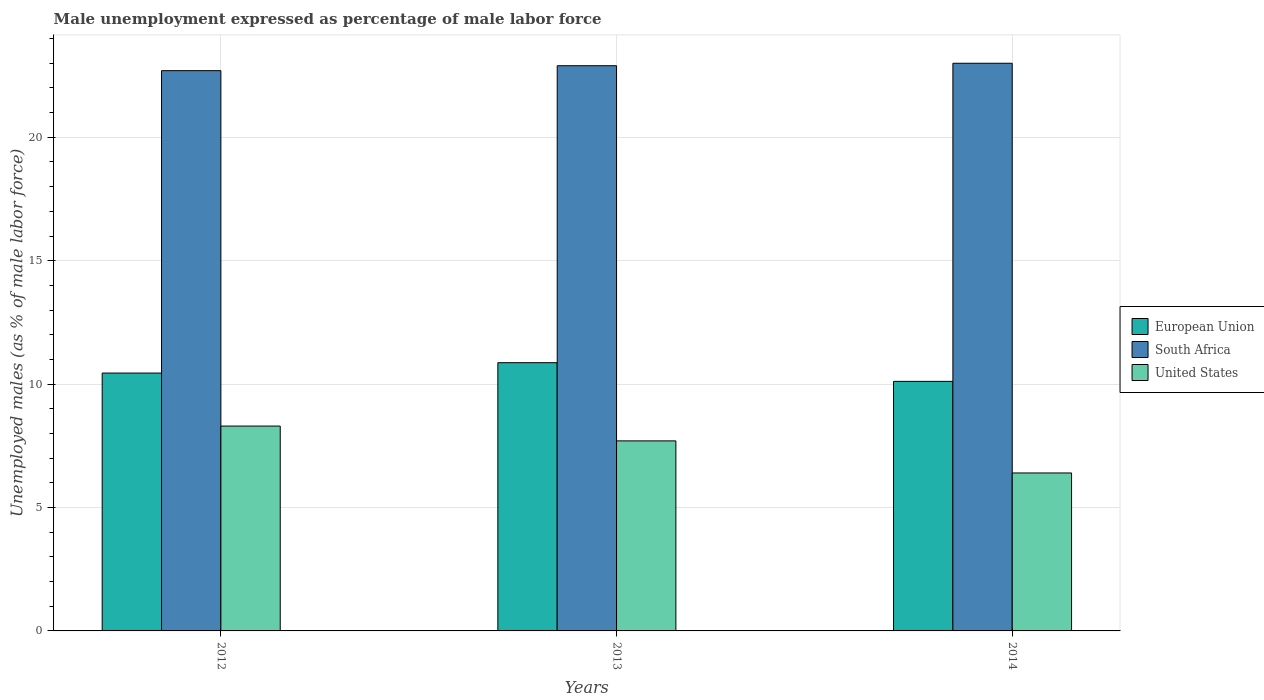How many groups of bars are there?
Provide a succinct answer. 3. Are the number of bars per tick equal to the number of legend labels?
Your answer should be compact. Yes. Are the number of bars on each tick of the X-axis equal?
Offer a terse response. Yes. How many bars are there on the 1st tick from the left?
Keep it short and to the point. 3. How many bars are there on the 2nd tick from the right?
Provide a short and direct response. 3. What is the label of the 1st group of bars from the left?
Give a very brief answer. 2012. What is the unemployment in males in in European Union in 2012?
Your answer should be very brief. 10.45. Across all years, what is the minimum unemployment in males in in United States?
Ensure brevity in your answer.  6.4. In which year was the unemployment in males in in European Union maximum?
Your answer should be very brief. 2013. In which year was the unemployment in males in in United States minimum?
Provide a succinct answer. 2014. What is the total unemployment in males in in United States in the graph?
Make the answer very short. 22.4. What is the difference between the unemployment in males in in South Africa in 2012 and that in 2013?
Give a very brief answer. -0.2. What is the difference between the unemployment in males in in South Africa in 2014 and the unemployment in males in in European Union in 2012?
Your answer should be very brief. 12.55. What is the average unemployment in males in in European Union per year?
Keep it short and to the point. 10.48. In the year 2012, what is the difference between the unemployment in males in in United States and unemployment in males in in South Africa?
Make the answer very short. -14.4. What is the ratio of the unemployment in males in in European Union in 2013 to that in 2014?
Provide a short and direct response. 1.07. Is the unemployment in males in in European Union in 2012 less than that in 2013?
Give a very brief answer. Yes. What is the difference between the highest and the second highest unemployment in males in in South Africa?
Your answer should be compact. 0.1. What is the difference between the highest and the lowest unemployment in males in in United States?
Provide a short and direct response. 1.9. In how many years, is the unemployment in males in in United States greater than the average unemployment in males in in United States taken over all years?
Keep it short and to the point. 2. Is it the case that in every year, the sum of the unemployment in males in in South Africa and unemployment in males in in European Union is greater than the unemployment in males in in United States?
Make the answer very short. Yes. How many years are there in the graph?
Your response must be concise. 3. Are the values on the major ticks of Y-axis written in scientific E-notation?
Offer a terse response. No. Does the graph contain grids?
Give a very brief answer. Yes. Where does the legend appear in the graph?
Your answer should be very brief. Center right. How are the legend labels stacked?
Offer a very short reply. Vertical. What is the title of the graph?
Provide a short and direct response. Male unemployment expressed as percentage of male labor force. What is the label or title of the X-axis?
Offer a very short reply. Years. What is the label or title of the Y-axis?
Give a very brief answer. Unemployed males (as % of male labor force). What is the Unemployed males (as % of male labor force) in European Union in 2012?
Keep it short and to the point. 10.45. What is the Unemployed males (as % of male labor force) in South Africa in 2012?
Provide a short and direct response. 22.7. What is the Unemployed males (as % of male labor force) of United States in 2012?
Make the answer very short. 8.3. What is the Unemployed males (as % of male labor force) in European Union in 2013?
Your answer should be compact. 10.87. What is the Unemployed males (as % of male labor force) of South Africa in 2013?
Give a very brief answer. 22.9. What is the Unemployed males (as % of male labor force) of United States in 2013?
Ensure brevity in your answer.  7.7. What is the Unemployed males (as % of male labor force) in European Union in 2014?
Provide a short and direct response. 10.11. What is the Unemployed males (as % of male labor force) of United States in 2014?
Provide a succinct answer. 6.4. Across all years, what is the maximum Unemployed males (as % of male labor force) of European Union?
Provide a succinct answer. 10.87. Across all years, what is the maximum Unemployed males (as % of male labor force) of South Africa?
Provide a short and direct response. 23. Across all years, what is the maximum Unemployed males (as % of male labor force) of United States?
Make the answer very short. 8.3. Across all years, what is the minimum Unemployed males (as % of male labor force) in European Union?
Your answer should be very brief. 10.11. Across all years, what is the minimum Unemployed males (as % of male labor force) of South Africa?
Ensure brevity in your answer.  22.7. Across all years, what is the minimum Unemployed males (as % of male labor force) in United States?
Provide a short and direct response. 6.4. What is the total Unemployed males (as % of male labor force) in European Union in the graph?
Ensure brevity in your answer.  31.43. What is the total Unemployed males (as % of male labor force) of South Africa in the graph?
Offer a terse response. 68.6. What is the total Unemployed males (as % of male labor force) of United States in the graph?
Offer a very short reply. 22.4. What is the difference between the Unemployed males (as % of male labor force) of European Union in 2012 and that in 2013?
Your response must be concise. -0.42. What is the difference between the Unemployed males (as % of male labor force) in South Africa in 2012 and that in 2013?
Provide a short and direct response. -0.2. What is the difference between the Unemployed males (as % of male labor force) of European Union in 2012 and that in 2014?
Provide a succinct answer. 0.34. What is the difference between the Unemployed males (as % of male labor force) in United States in 2012 and that in 2014?
Provide a short and direct response. 1.9. What is the difference between the Unemployed males (as % of male labor force) of European Union in 2013 and that in 2014?
Ensure brevity in your answer.  0.76. What is the difference between the Unemployed males (as % of male labor force) in South Africa in 2013 and that in 2014?
Keep it short and to the point. -0.1. What is the difference between the Unemployed males (as % of male labor force) of European Union in 2012 and the Unemployed males (as % of male labor force) of South Africa in 2013?
Offer a very short reply. -12.45. What is the difference between the Unemployed males (as % of male labor force) of European Union in 2012 and the Unemployed males (as % of male labor force) of United States in 2013?
Keep it short and to the point. 2.75. What is the difference between the Unemployed males (as % of male labor force) of South Africa in 2012 and the Unemployed males (as % of male labor force) of United States in 2013?
Give a very brief answer. 15. What is the difference between the Unemployed males (as % of male labor force) in European Union in 2012 and the Unemployed males (as % of male labor force) in South Africa in 2014?
Make the answer very short. -12.55. What is the difference between the Unemployed males (as % of male labor force) of European Union in 2012 and the Unemployed males (as % of male labor force) of United States in 2014?
Give a very brief answer. 4.05. What is the difference between the Unemployed males (as % of male labor force) in European Union in 2013 and the Unemployed males (as % of male labor force) in South Africa in 2014?
Your response must be concise. -12.13. What is the difference between the Unemployed males (as % of male labor force) of European Union in 2013 and the Unemployed males (as % of male labor force) of United States in 2014?
Your answer should be compact. 4.47. What is the average Unemployed males (as % of male labor force) of European Union per year?
Your response must be concise. 10.48. What is the average Unemployed males (as % of male labor force) of South Africa per year?
Offer a very short reply. 22.87. What is the average Unemployed males (as % of male labor force) of United States per year?
Ensure brevity in your answer.  7.47. In the year 2012, what is the difference between the Unemployed males (as % of male labor force) in European Union and Unemployed males (as % of male labor force) in South Africa?
Your answer should be compact. -12.25. In the year 2012, what is the difference between the Unemployed males (as % of male labor force) of European Union and Unemployed males (as % of male labor force) of United States?
Provide a succinct answer. 2.15. In the year 2012, what is the difference between the Unemployed males (as % of male labor force) of South Africa and Unemployed males (as % of male labor force) of United States?
Your answer should be very brief. 14.4. In the year 2013, what is the difference between the Unemployed males (as % of male labor force) of European Union and Unemployed males (as % of male labor force) of South Africa?
Your answer should be compact. -12.03. In the year 2013, what is the difference between the Unemployed males (as % of male labor force) in European Union and Unemployed males (as % of male labor force) in United States?
Your answer should be very brief. 3.17. In the year 2014, what is the difference between the Unemployed males (as % of male labor force) in European Union and Unemployed males (as % of male labor force) in South Africa?
Make the answer very short. -12.89. In the year 2014, what is the difference between the Unemployed males (as % of male labor force) of European Union and Unemployed males (as % of male labor force) of United States?
Provide a succinct answer. 3.71. In the year 2014, what is the difference between the Unemployed males (as % of male labor force) of South Africa and Unemployed males (as % of male labor force) of United States?
Ensure brevity in your answer.  16.6. What is the ratio of the Unemployed males (as % of male labor force) of European Union in 2012 to that in 2013?
Keep it short and to the point. 0.96. What is the ratio of the Unemployed males (as % of male labor force) in South Africa in 2012 to that in 2013?
Give a very brief answer. 0.99. What is the ratio of the Unemployed males (as % of male labor force) of United States in 2012 to that in 2013?
Give a very brief answer. 1.08. What is the ratio of the Unemployed males (as % of male labor force) of European Union in 2012 to that in 2014?
Your answer should be compact. 1.03. What is the ratio of the Unemployed males (as % of male labor force) of United States in 2012 to that in 2014?
Offer a very short reply. 1.3. What is the ratio of the Unemployed males (as % of male labor force) of European Union in 2013 to that in 2014?
Your answer should be compact. 1.07. What is the ratio of the Unemployed males (as % of male labor force) of United States in 2013 to that in 2014?
Provide a succinct answer. 1.2. What is the difference between the highest and the second highest Unemployed males (as % of male labor force) of European Union?
Offer a very short reply. 0.42. What is the difference between the highest and the second highest Unemployed males (as % of male labor force) in United States?
Make the answer very short. 0.6. What is the difference between the highest and the lowest Unemployed males (as % of male labor force) of European Union?
Offer a very short reply. 0.76. What is the difference between the highest and the lowest Unemployed males (as % of male labor force) in South Africa?
Provide a short and direct response. 0.3. What is the difference between the highest and the lowest Unemployed males (as % of male labor force) of United States?
Ensure brevity in your answer.  1.9. 